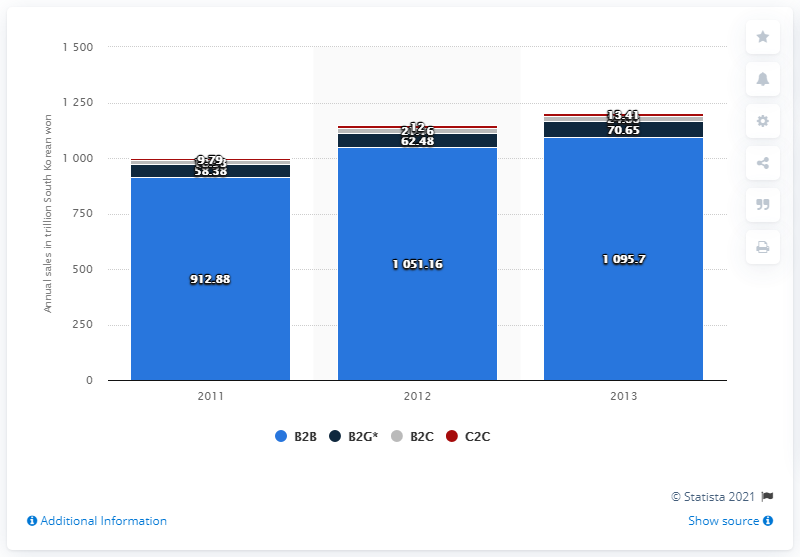Point out several critical features in this image. In 2013, the total value of e-commerce transactions in South Korea was 1095.7 million South Korean won. 